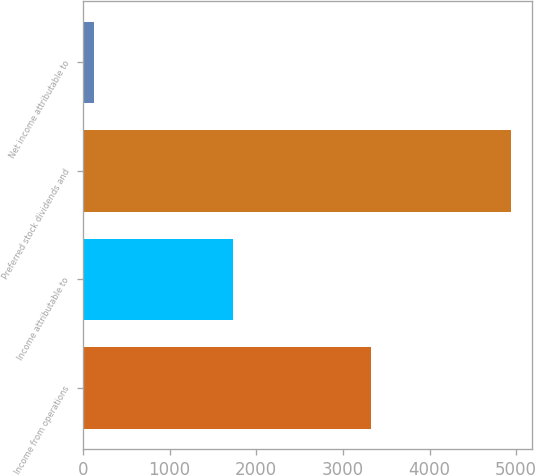Convert chart. <chart><loc_0><loc_0><loc_500><loc_500><bar_chart><fcel>Income from operations<fcel>Income attributable to<fcel>Preferred stock dividends and<fcel>Net income attributable to<nl><fcel>3322.6<fcel>1726.8<fcel>4934<fcel>131<nl></chart> 